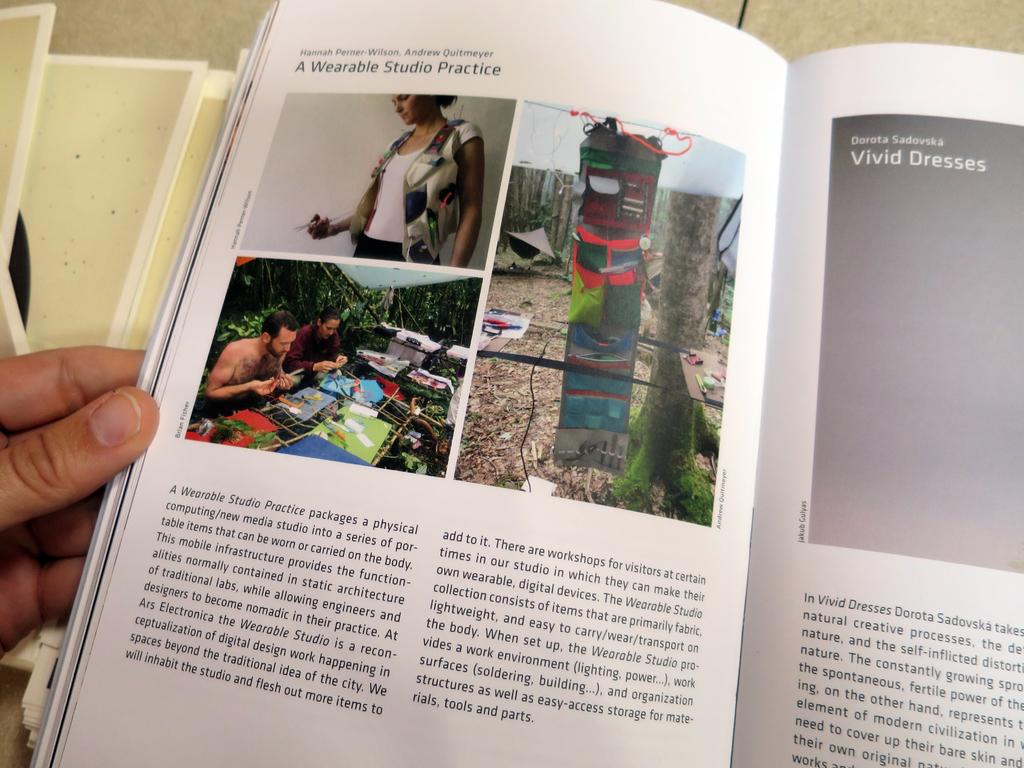What can be seen in the image that belongs to a person? There is a person's hand in the image. What object is present on a surface in the image? There is a book on a surface in the image. What types of content are included in the book? The book contains images of people, trees, and objects, as well as text. What color is the crow that is captioned in the image? There is no crow present in the image, nor is there any caption. What type of fruit is being held by the person in the image? There is no fruit visible in the image, and the person's hand is the only part of a person shown. 